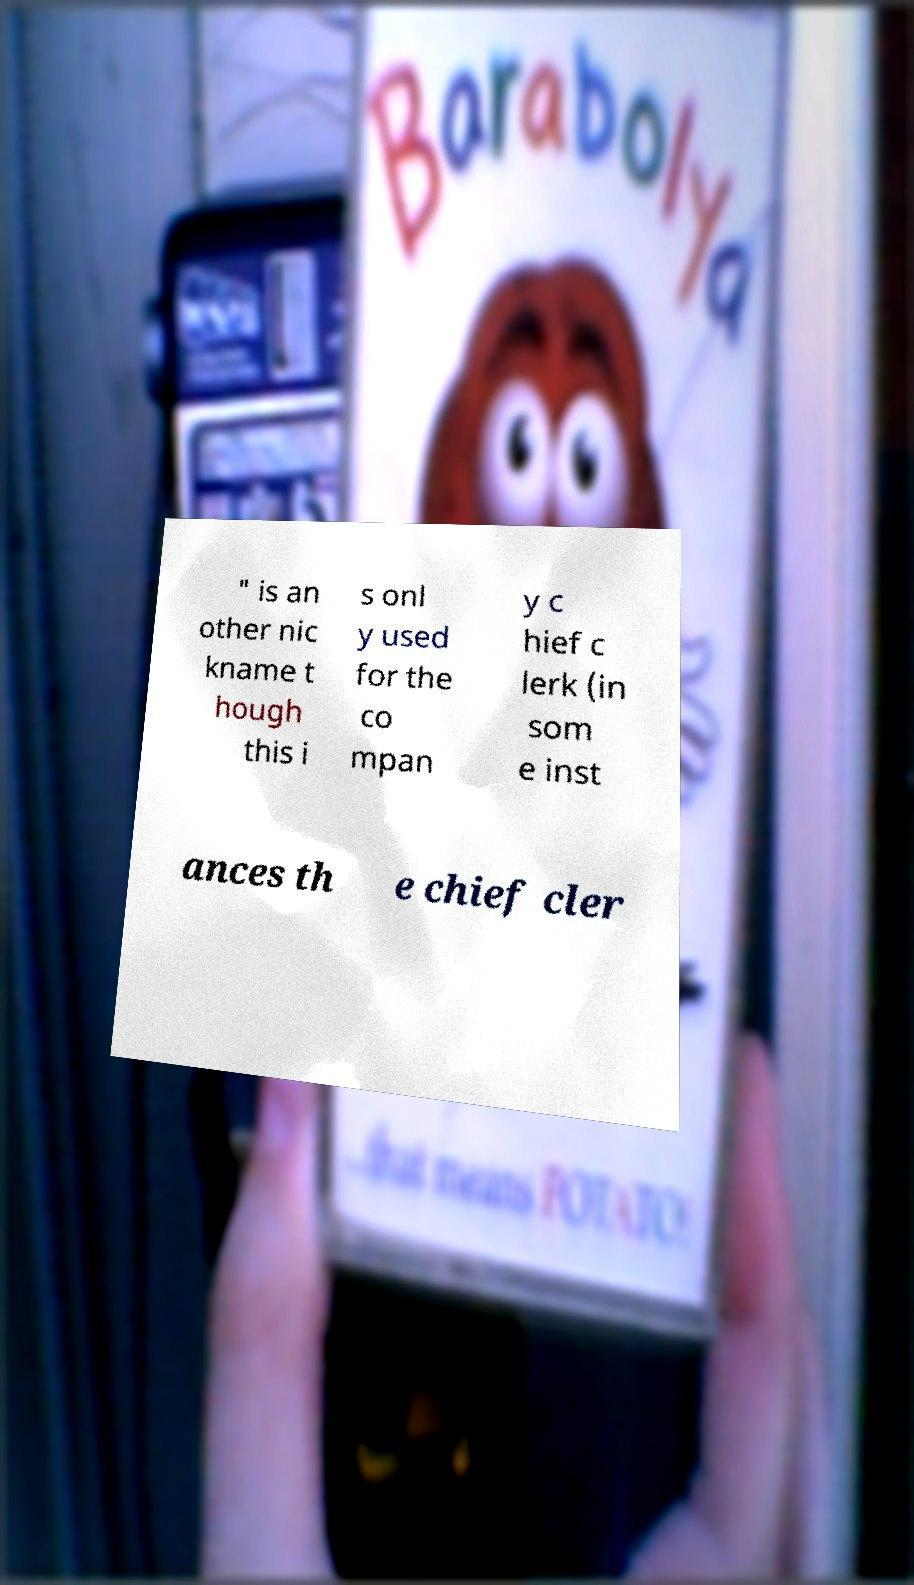There's text embedded in this image that I need extracted. Can you transcribe it verbatim? " is an other nic kname t hough this i s onl y used for the co mpan y c hief c lerk (in som e inst ances th e chief cler 